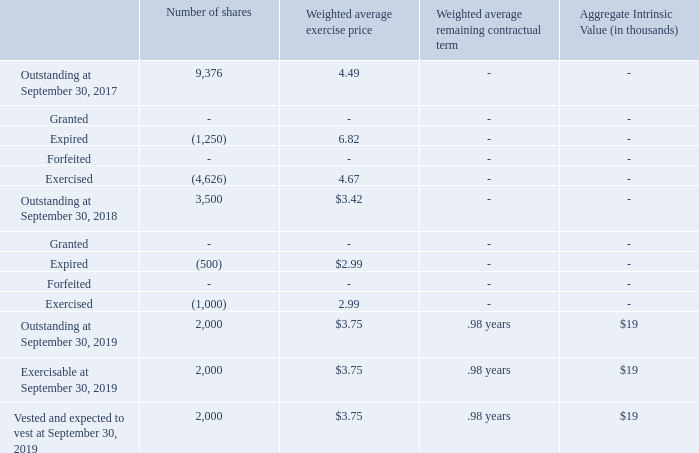As stock-based compensation expense recognized in the consolidated statements of operations is based on awards ultimately expected to vest, expense for grants beginning upon adoption on October 1, 2005 has been reduced for estimated forfeitures. Forfeitures are estimated at the time of grant and revised, if necessary, in subsequent periods if actual forfeitures differ from those estimates. The forfeiture rates for the years ended September 30, 2019 and 2018 were based on actual forfeitures.
No cash was used to settle equity instruments granted under share-base payment arrangements in any of the years in the two-year period ended September 30, 2019.
The following tables provide summary data of stock option award activity:
What is the number of outstanding shares as at September 30, 2017?
Answer scale should be: thousand. 9,376. When was stock based compensation adopted by the company?
Answer scale should be: thousand. October 1, 2005. What is the number of shares vested and expected to vest at September 30, 2019
Answer scale should be: thousand. 2,000. What is the amount lost from the expired shares in 2017?
Answer scale should be: thousand. 1,250 * 6.82 
Answer: 8525. What is the total number of expired shares in 2017 and 2018? 1,250 + 500 
Answer: 1750. What is the percentage of outstanding shares as at September 30, 2019 expired between September 30, 2018 and 2019?
Answer scale should be: percent. 500/2,000 
Answer: 25. 